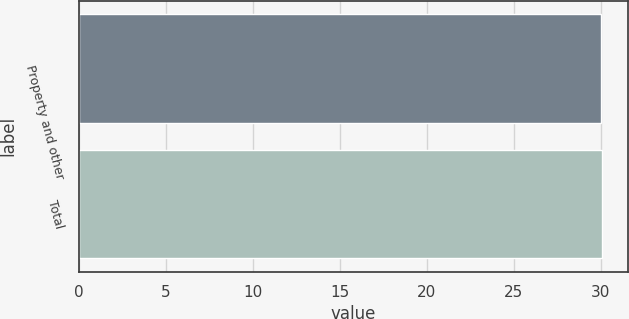Convert chart. <chart><loc_0><loc_0><loc_500><loc_500><bar_chart><fcel>Property and other<fcel>Total<nl><fcel>30<fcel>30.1<nl></chart> 